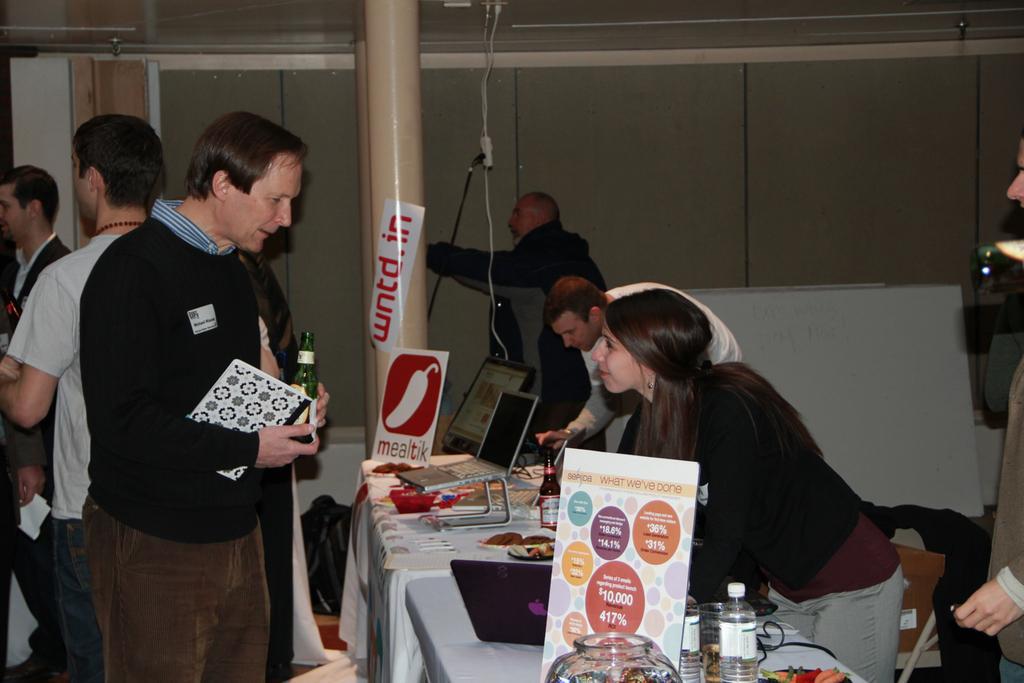In one or two sentences, can you explain what this image depicts? There are some persons standing on the floor. These are the tables. On the table there are laptops, bottles, and glasses. On the background there is a wall and this is pole. And these are the boards. 